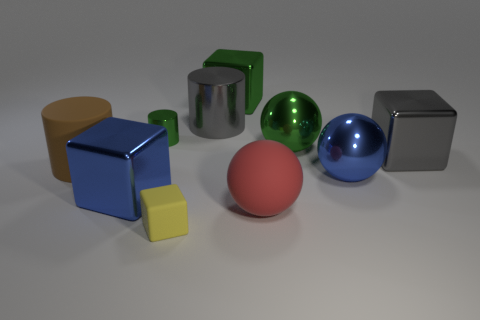Do the big metal cube to the right of the red matte thing and the small thing that is to the left of the matte block have the same color?
Keep it short and to the point. No. What number of cubes are either big blue metallic objects or large red matte things?
Provide a short and direct response. 1. Are there an equal number of large blue balls that are left of the gray metal cylinder and big green blocks?
Provide a succinct answer. No. There is a cylinder on the right side of the tiny object in front of the large object right of the large blue sphere; what is it made of?
Your answer should be very brief. Metal. There is a large thing that is the same color as the big metallic cylinder; what is it made of?
Provide a succinct answer. Metal. How many objects are either big things behind the big brown matte cylinder or big brown rubber objects?
Ensure brevity in your answer.  5. How many objects are large cylinders or large things right of the green block?
Offer a very short reply. 6. There is a rubber object to the left of the big metal block to the left of the small yellow rubber cube; how many large matte cylinders are in front of it?
Offer a very short reply. 0. There is a cylinder that is the same size as the matte cube; what is its material?
Offer a terse response. Metal. Is there a gray metal cube that has the same size as the green block?
Make the answer very short. Yes. 